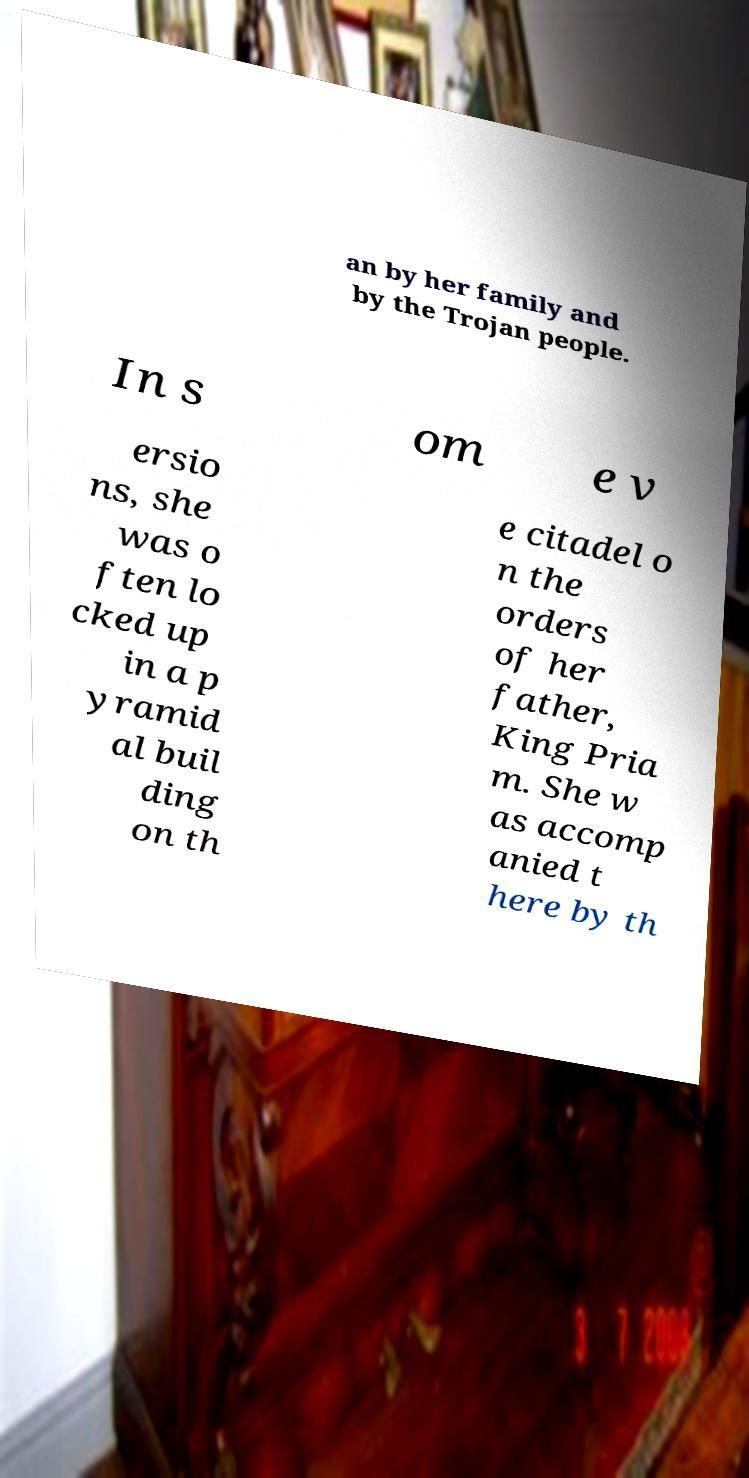For documentation purposes, I need the text within this image transcribed. Could you provide that? an by her family and by the Trojan people. In s om e v ersio ns, she was o ften lo cked up in a p yramid al buil ding on th e citadel o n the orders of her father, King Pria m. She w as accomp anied t here by th 